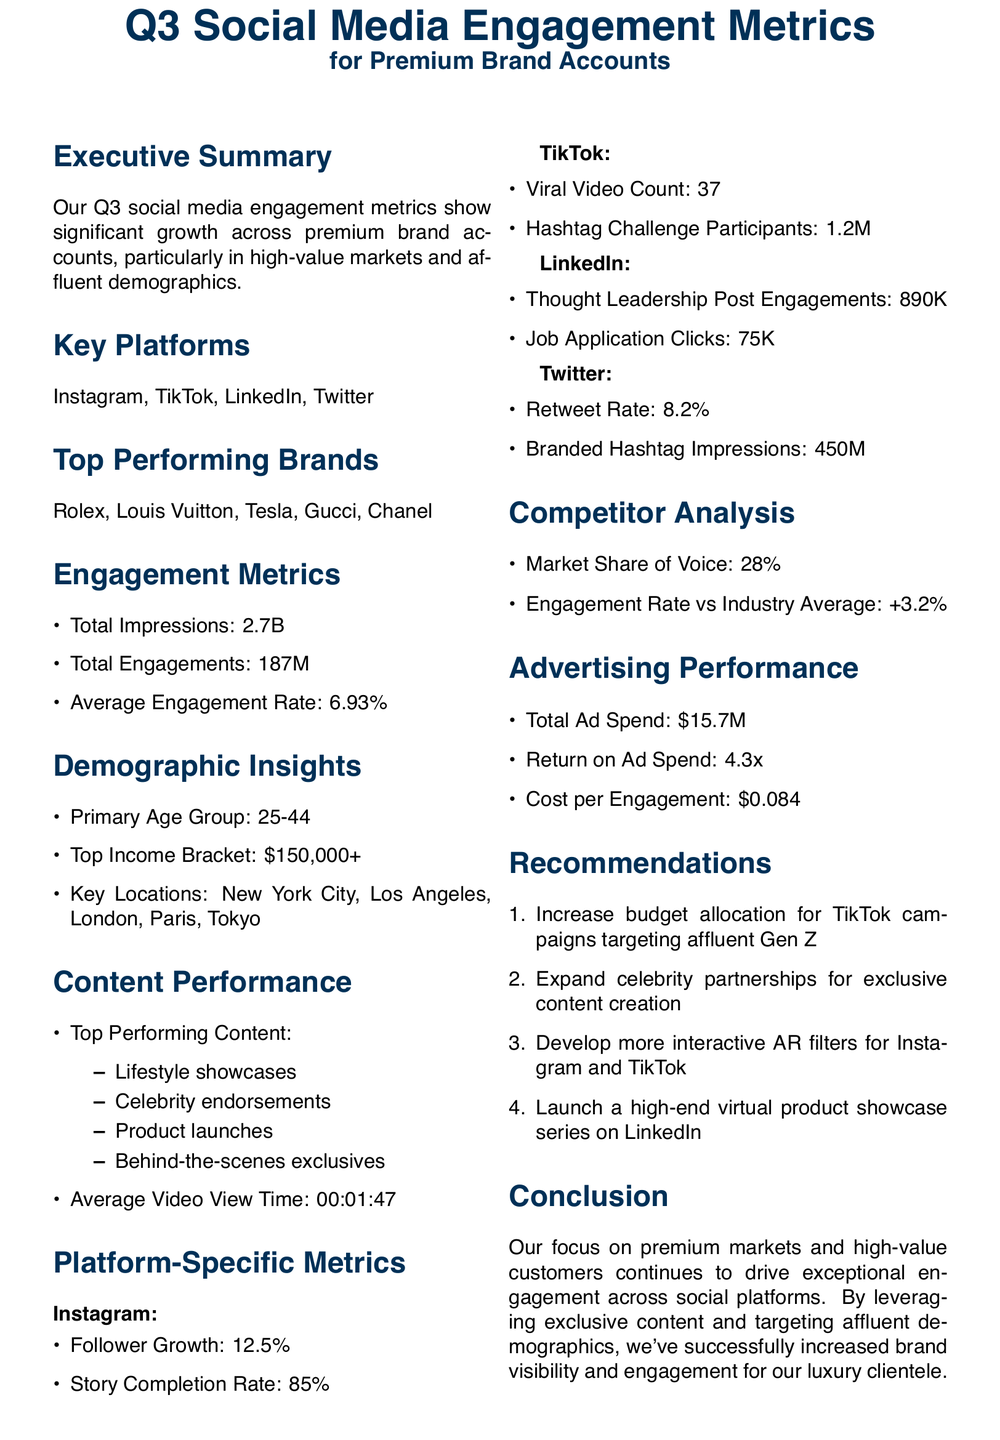What is the total number of impressions? The total impressions are listed under engagement metrics as 2.7 billion.
Answer: 2.7B Which platform had a 12.5% follower growth? The specific platform with 12.5% follower growth is mentioned under platform-specific metrics.
Answer: Instagram What is the primary age group targeted? The primary age group is identified in the demographic insights section of the document.
Answer: 25-44 How many viral videos were created on TikTok? The viral video count on TikTok is provided in the platform-specific metrics section.
Answer: 37 What is the average engagement rate? The average engagement rate is specified in the engagement metrics section of the memo.
Answer: 6.93% What is the return on ad spend? The return on ad spend can be found in the advertising performance section of the document.
Answer: 4.3x Which city is listed as a key location? The key locations are listed in the demographic insights section, naming several cities.
Answer: New York City How many hashtag challenge participants were on TikTok? The number of hashtag challenge participants is recorded in the TikTok-specific metrics.
Answer: 1.2M What type of content is recommended to be developed? The recommendations section suggests developing more of a particular type of content.
Answer: Interactive AR filters 